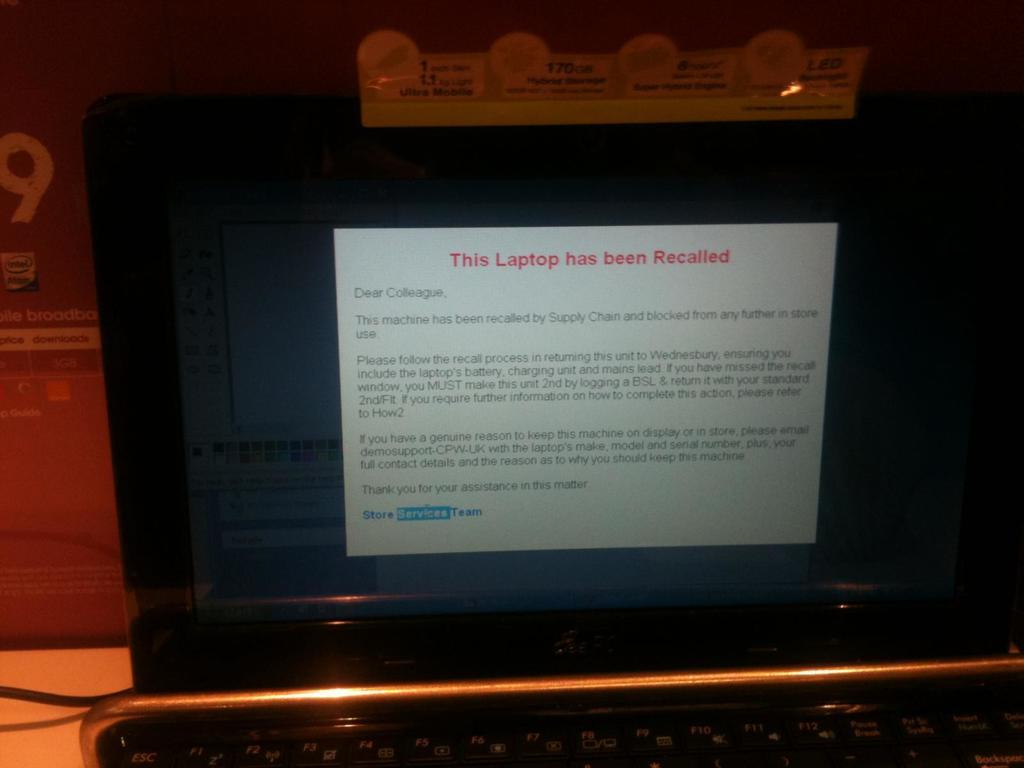<image>
Share a concise interpretation of the image provided. An open laptop with This laptop has been recalled written on the screen 